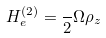<formula> <loc_0><loc_0><loc_500><loc_500>H _ { e } ^ { ( 2 ) } = \frac { } { 2 } \Omega \rho _ { z }</formula> 